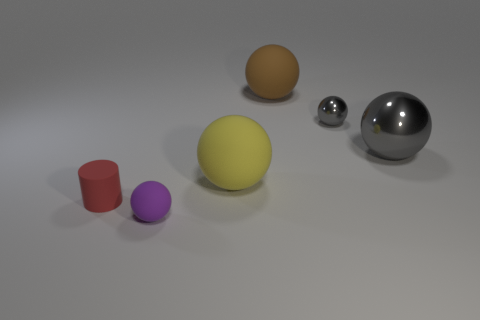How do the objects in the image vary in size? The objects in the image exhibit a diverse range of sizes, from the small silver sphere to the much larger yellow and orange spheres. The purple cylinder and red cup are smaller in scale compared to the spheres, with the cylinder being the smallest of them all. 